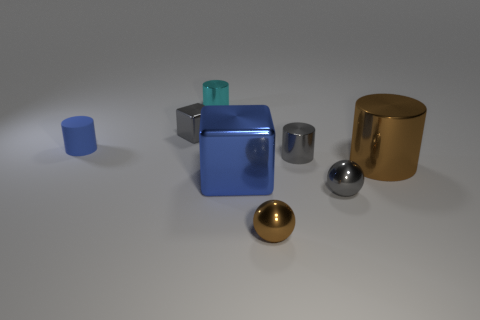Aside from the big brown cylinder, are there other objects made of metal? Yes, several objects appear to be made of metal. The sphere, the small cylinder next to it, and the half-sphere have reflective surfaces that suggest they are metallic. The sphere, with its mirror-like finish, particularly suggests a chrome or polished steel material. 